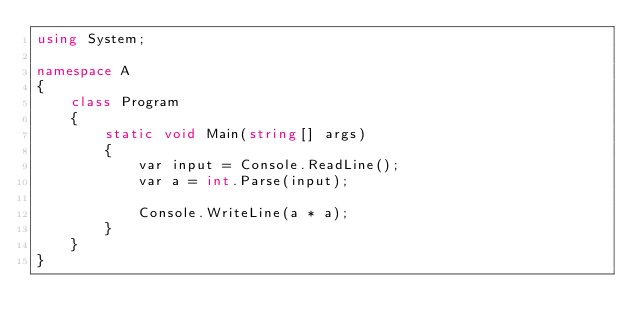Convert code to text. <code><loc_0><loc_0><loc_500><loc_500><_C#_>using System;

namespace A
{
    class Program
    {
        static void Main(string[] args)
        {
            var input = Console.ReadLine();
            var a = int.Parse(input);

            Console.WriteLine(a * a);
        }
    }
}
</code> 